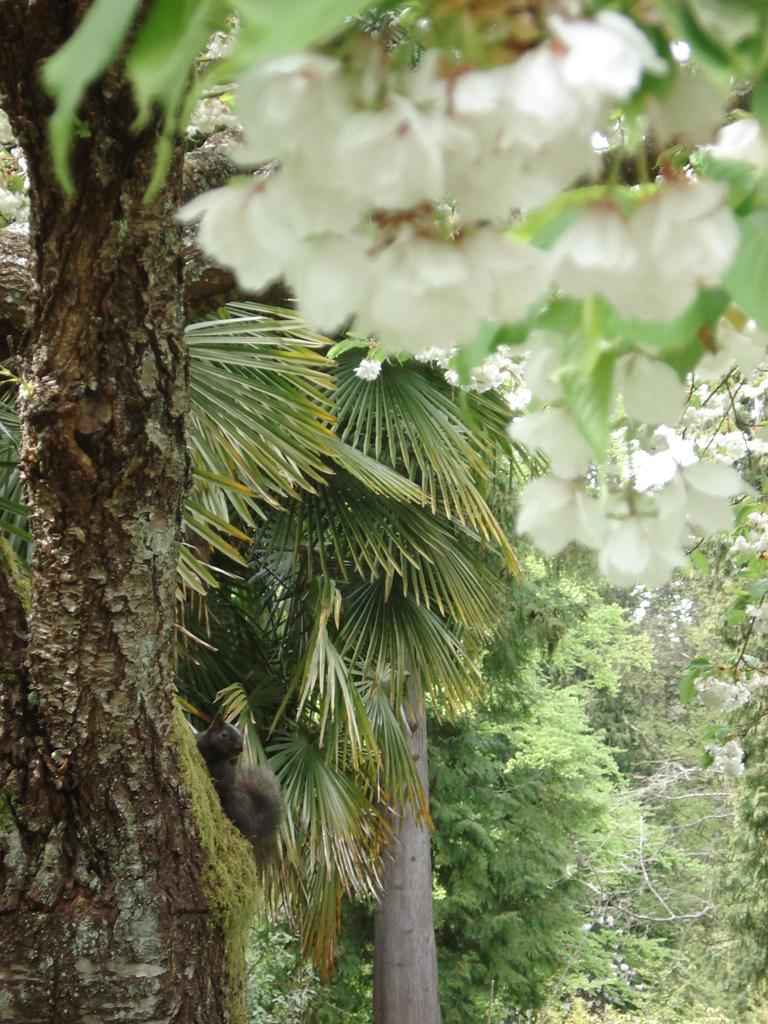What is the main subject of the image? The main subject of the image is a bunch of flowers with leaves. Can you describe the flowers in the image? The flowers have leaves attached to them. What can be seen in the background of the image? There are trees in the background of the image. What invention is being demonstrated in the image? There is no invention being demonstrated in the image; it features a bunch of flowers with leaves and trees in the background. What is the taste of the flowers in the image? The taste of the flowers cannot be determined from the image, as it is a visual representation and does not convey taste. 